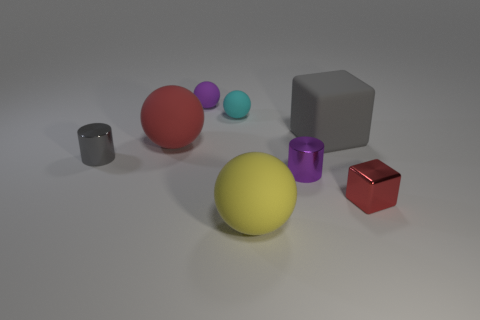What material is the gray thing that is the same size as the yellow matte ball?
Keep it short and to the point. Rubber. Is there another tiny object that has the same material as the tiny cyan object?
Provide a short and direct response. Yes. The metallic cylinder to the right of the tiny thing to the left of the small purple thing behind the small purple shiny object is what color?
Offer a terse response. Purple. There is a small cylinder that is to the right of the red ball; is its color the same as the big ball behind the gray metal thing?
Offer a very short reply. No. Are there any other things of the same color as the small block?
Your answer should be compact. Yes. Is the number of red rubber spheres in front of the tiny gray thing less than the number of gray cylinders?
Keep it short and to the point. Yes. What number of large blue balls are there?
Offer a very short reply. 0. There is a big red rubber thing; is its shape the same as the rubber object that is in front of the red rubber sphere?
Ensure brevity in your answer.  Yes. Are there fewer large yellow spheres that are to the right of the large cube than metallic things that are in front of the small cyan thing?
Make the answer very short. Yes. Is the red rubber thing the same shape as the tiny gray metal object?
Provide a short and direct response. No. 